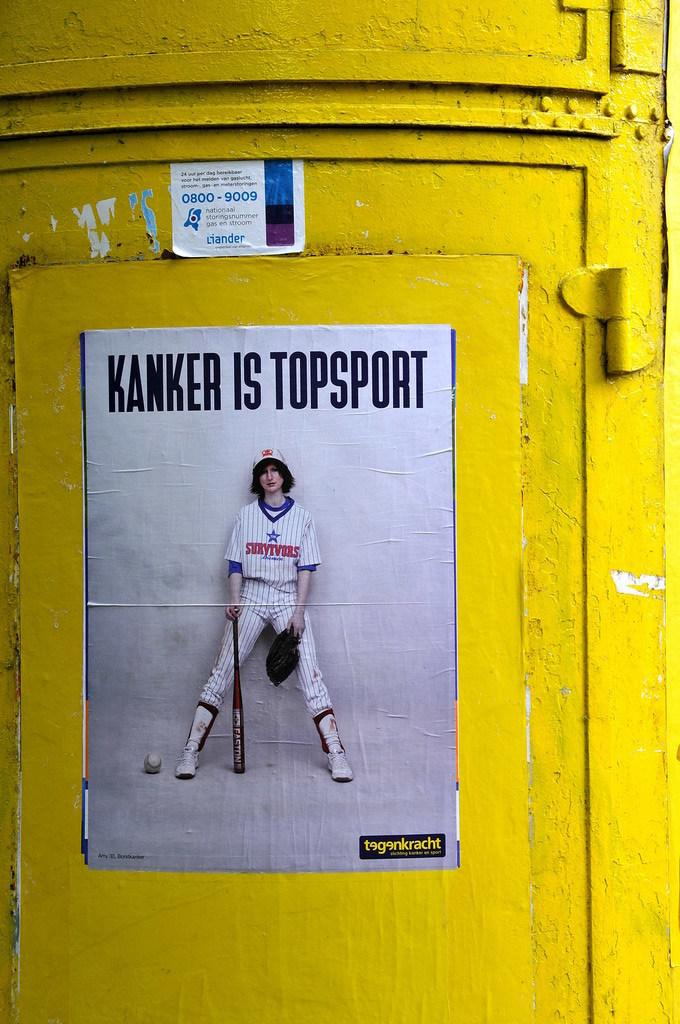<image>
Render a clear and concise summary of the photo. A sign showing a baseball player says Kanker is Topsport. 